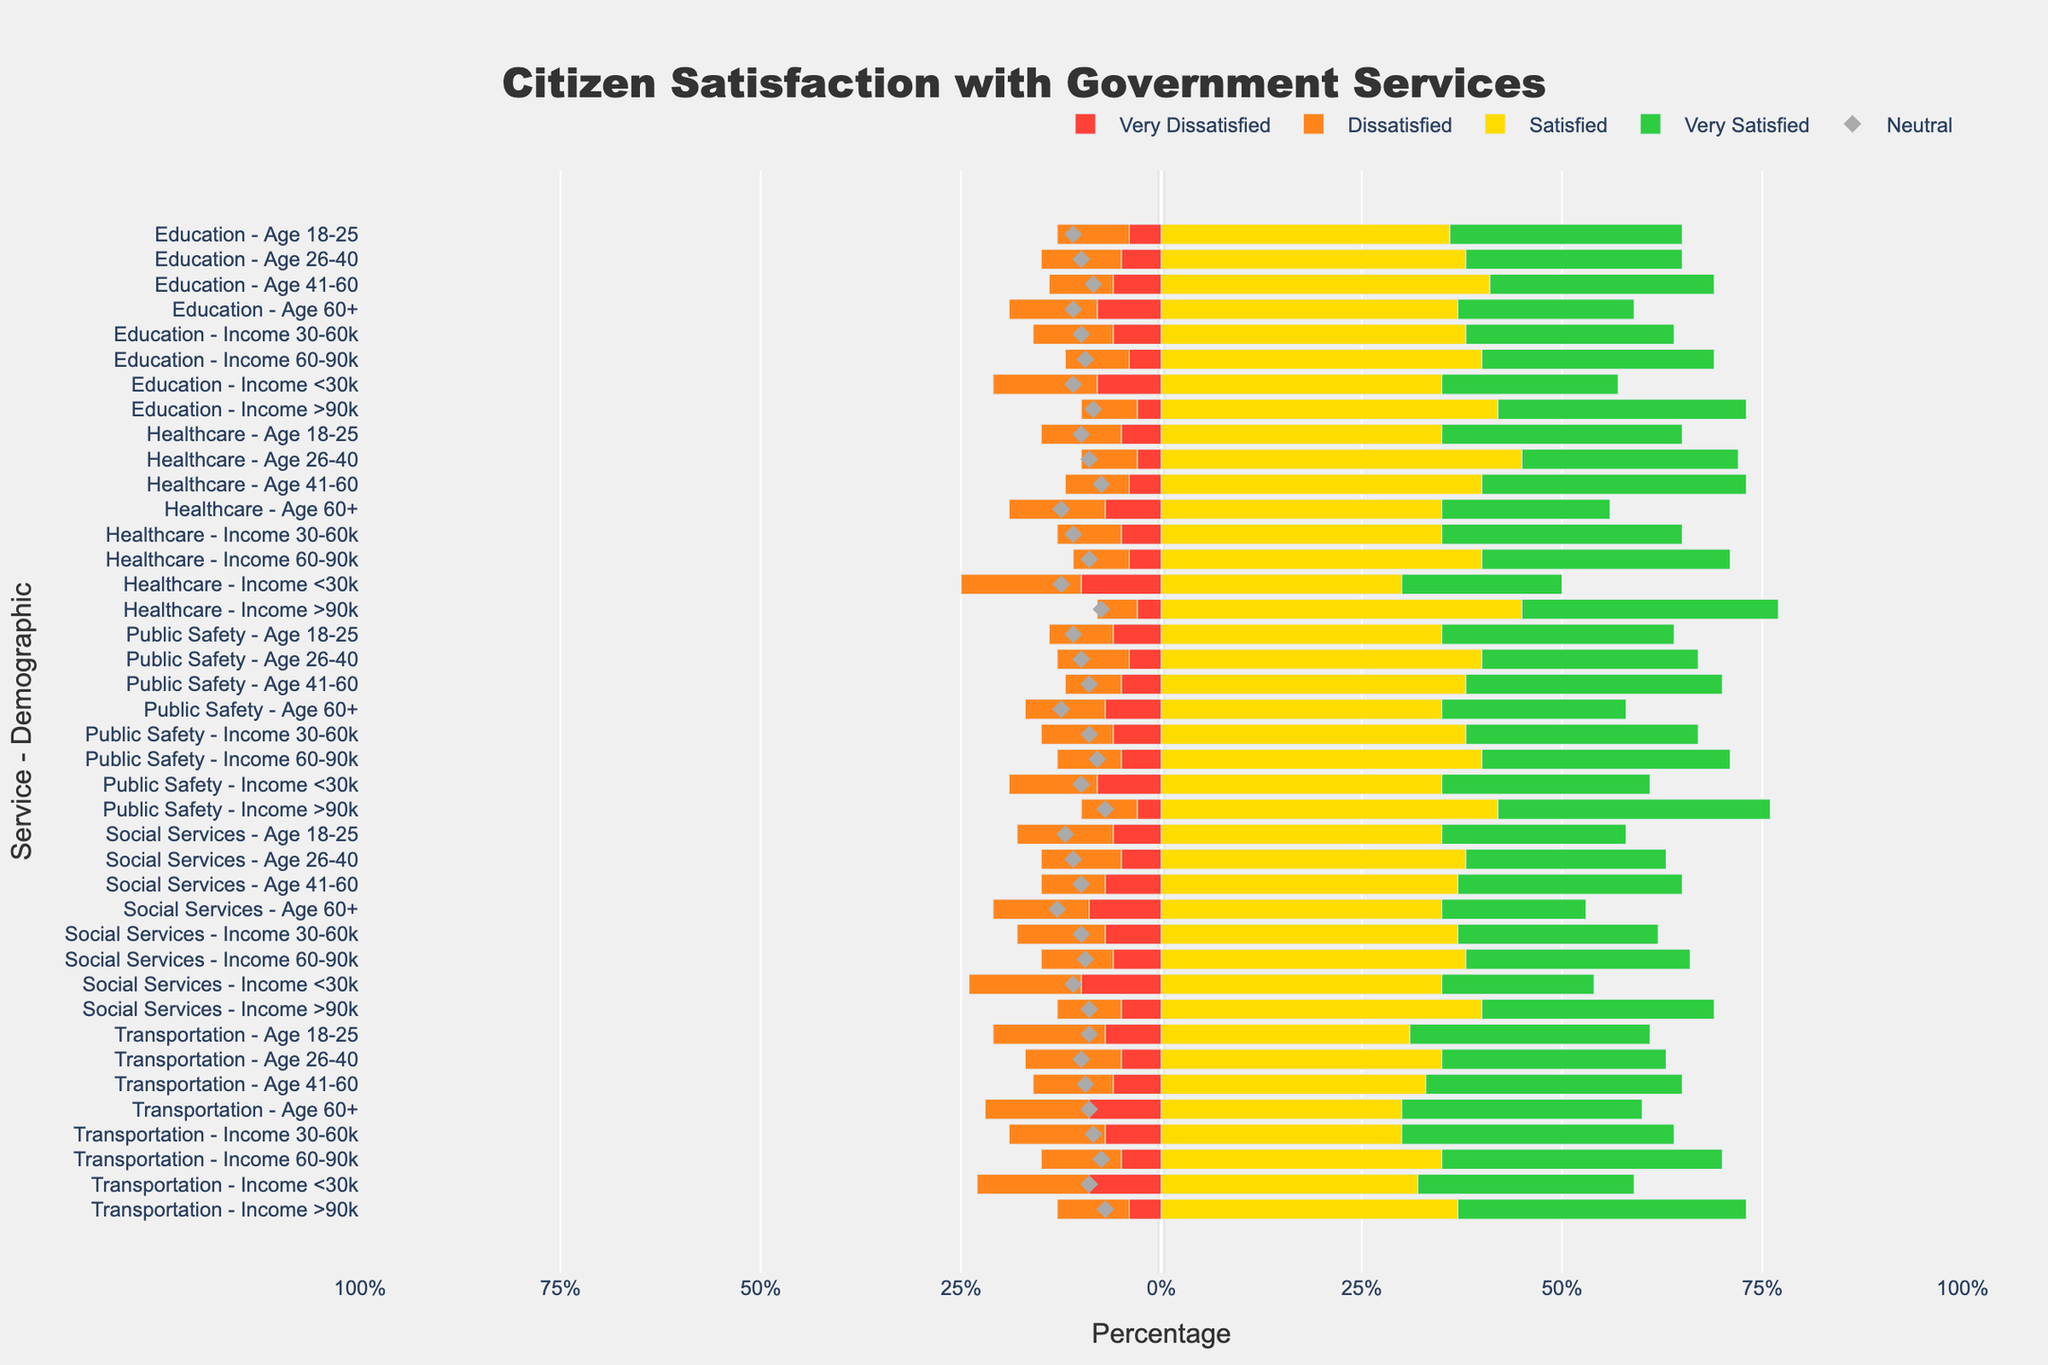What is the level of satisfaction with Healthcare services for people aged 26-40 compared to those aged 60+? Looking at the Diverging Stacked Bar Chart for Healthcare services, we observe the percentage of satisfaction levels. For people aged 26-40, 'Very Satisfied' is 27% and 'Satisfied' is 45%, making it 72% in total. For people aged 60+, 'Very Satisfied' is 21% and 'Satisfied' is 35%, making it 56%. Therefore, people aged 26-40 are more satisfied with Healthcare services compared to those aged 60+.
Answer: People aged 26-40 are more satisfied compared to those aged 60+ Which demographic group shows the highest percentage of dissatisfaction with Transportation services? From the Diverging Stacked Bar Chart, we can see that the group "Income <30k" has the highest percentage of 'Very Dissatisfied' (9%) and 'Dissatisfied' (14%) resulting in a combined dissatisfaction of 23%. This is the highest among the groups for Transportation services.
Answer: Income <30k What is the overall satisfaction rate (sum of Satisfied and Very Satisfied) for Education services for people aged 41-60? Referring to the chart for Education services in the age group 41-60, the 'Satisfied' percentage is 41%, and the 'Very Satisfied' percentage is 28%. To find the overall satisfaction rate, we sum these percentages: 41% + 28% = 69%.
Answer: 69% Compare the satisfaction levels for Public Safety services between the age groups 18-25 and 41-60. Which age group has a higher combined rate of 'Satisfied' and 'Very Satisfied'? For Public Safety services, people aged 18-25 have a 'Satisfied' percentage of 35% and 'Very Satisfied' percentage of 29%, summing to 64%. Those aged 41-60 have a 'Satisfied' percentage of 38% and 'Very Satisfied' percentage of 32%, summing to 70%. Hence, the age group 41-60 shows higher satisfaction levels.
Answer: People aged 41-60 In Social Services for those with Income 30-60k, how does the percentage of 'Neutral' compare to those with Income >90k? In the chart for Social Services, the Income 30-60k group has a 'Neutral' percentage of 20%. Comparatively, the Income >90k group has a 'Neutral' percentage of 18%. Therefore, the 'Neutral' percentage is slightly higher for the Income 30-60k group.
Answer: Income 30-60k has a higher 'Neutral' percentage How does the level of 'Very Dissatisfied' for Healthcare services for those with Income <30k compare with Income >90k? Observing the chart for Healthcare services, the 'Very Dissatisfied' percentage for those with Income <30k is 10%, while for those with Income >90k, it is 3%. Thus, the percentage of 'Very Dissatisfied' is higher for the Income <30k group compared to the Income >90k group.
Answer: Higher for Income <30k What is the combined dissatisfaction rate (sum of Very Dissatisfied and Dissatisfied) for Social Services for people aged 60+? In Social Services for the age group 60+, the 'Very Dissatisfied' percentage is 9% and the 'Dissatisfied' percentage is 12%. The combined dissatisfaction rate is 9% + 12% = 21%.
Answer: 21% Between Education and Healthcare services for people aged 18-25, which service has a higher percentage of 'Very Satisfied'? The chart shows that for Education services, the 'Very Satisfied' percentage for people aged 18-25 is 29%, while for Healthcare services, it is 30%. Therefore, Healthcare services have a slightly higher percentage of 'Very Satisfied'.
Answer: Healthcare services Which income group shows the highest percentage of 'Very Satisfied' for Transportation services? By examining the chart, the highest 'Very Satisfied' percentage for Transportation services is for the Income >90k group, which stands at 36%.
Answer: Income >90k For Public Safety services in the Income 60-90k group, how does the percentage of 'Very Dissatisfied' compare to that of the Income <30k group? For Public Safety services, the Income 60-90k group has a 'Very Dissatisfied' percentage of 5%, while the Income <30k group has 8%. Therefore, the percentage of 'Very Dissatisfied' is lower in the Income 60-90k group compared to the Income <30k group.
Answer: Lower in Income 60-90k 